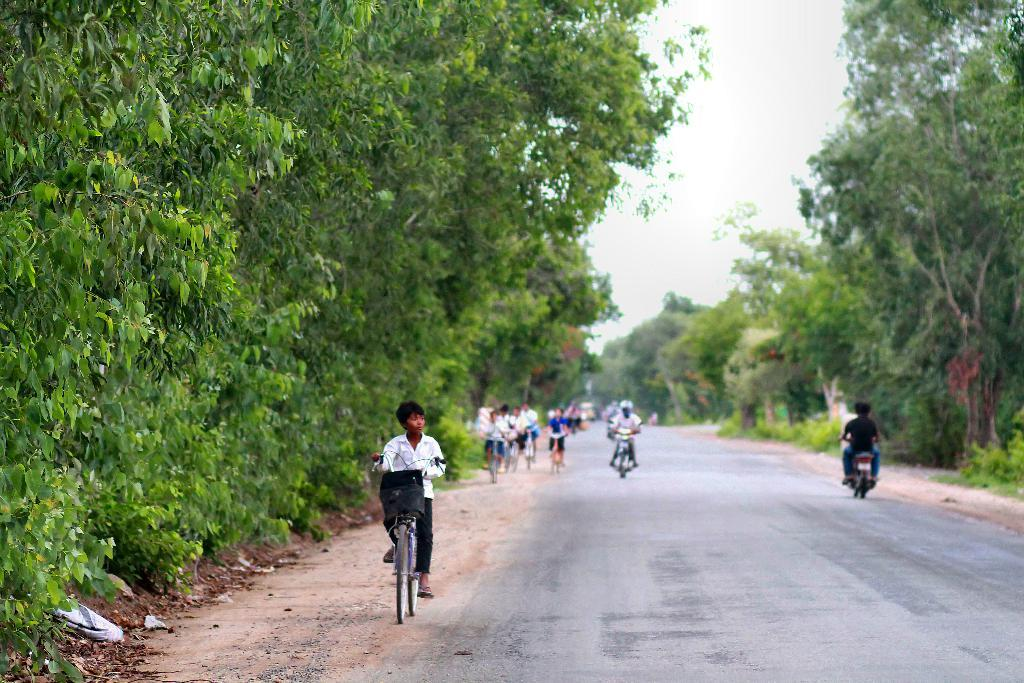What are the persons in the image doing? The persons in the image are riding bicycles. What type of vehicles are present in the image? There are bicycles in the image. Where are the bicycles located? The bicycles are on the road. What can be seen in the background of the image? There are trees and the sky visible in the background of the image. What is the condition of the sky in the image? Clouds are present in the sky. Can you tell me how many yaks are pulling the bicycles in the image? There are no yaks present in the image; the bicycles are being ridden by persons. What type of sack is being carried by the laborer in the image? There is no laborer or sack present in the image. 